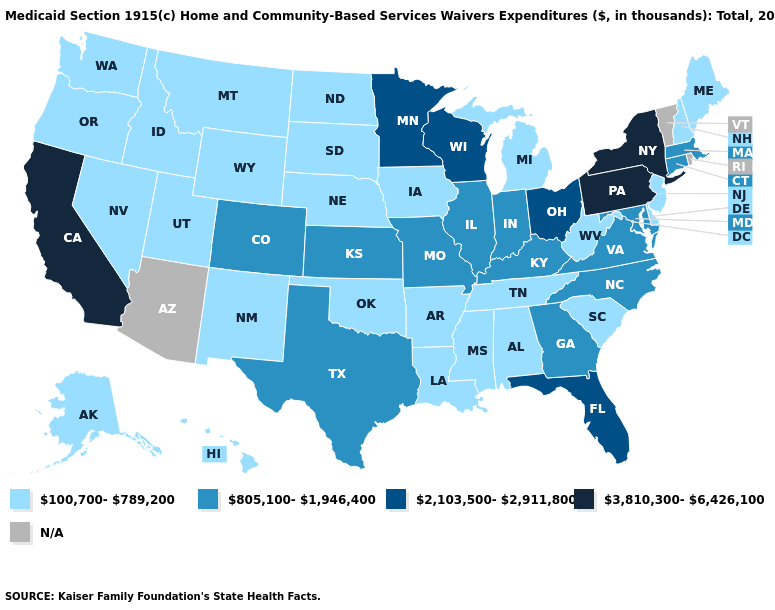Name the states that have a value in the range N/A?
Concise answer only. Arizona, Rhode Island, Vermont. Does Maryland have the lowest value in the South?
Be succinct. No. Among the states that border Minnesota , does South Dakota have the highest value?
Give a very brief answer. No. Name the states that have a value in the range 3,810,300-6,426,100?
Give a very brief answer. California, New York, Pennsylvania. Does Alaska have the lowest value in the West?
Give a very brief answer. Yes. Is the legend a continuous bar?
Write a very short answer. No. Does the map have missing data?
Be succinct. Yes. Which states hav the highest value in the Northeast?
Keep it brief. New York, Pennsylvania. Name the states that have a value in the range 805,100-1,946,400?
Give a very brief answer. Colorado, Connecticut, Georgia, Illinois, Indiana, Kansas, Kentucky, Maryland, Massachusetts, Missouri, North Carolina, Texas, Virginia. Name the states that have a value in the range N/A?
Short answer required. Arizona, Rhode Island, Vermont. Is the legend a continuous bar?
Write a very short answer. No. How many symbols are there in the legend?
Concise answer only. 5. Among the states that border North Dakota , which have the highest value?
Give a very brief answer. Minnesota. Which states hav the highest value in the South?
Concise answer only. Florida. 